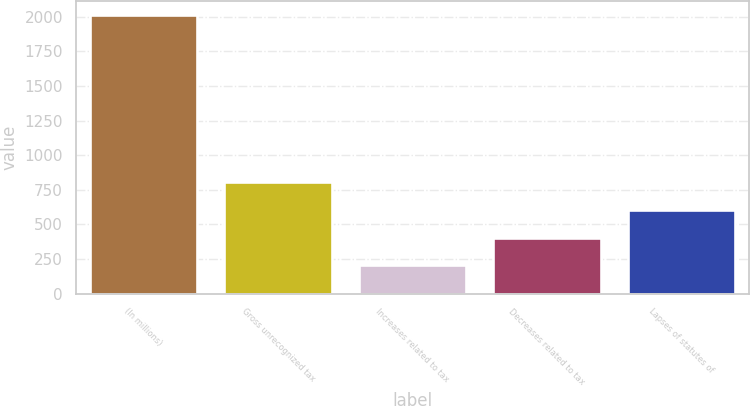<chart> <loc_0><loc_0><loc_500><loc_500><bar_chart><fcel>(In millions)<fcel>Gross unrecognized tax<fcel>Increases related to tax<fcel>Decreases related to tax<fcel>Lapses of statutes of<nl><fcel>2010<fcel>805.8<fcel>203.7<fcel>404.4<fcel>605.1<nl></chart> 